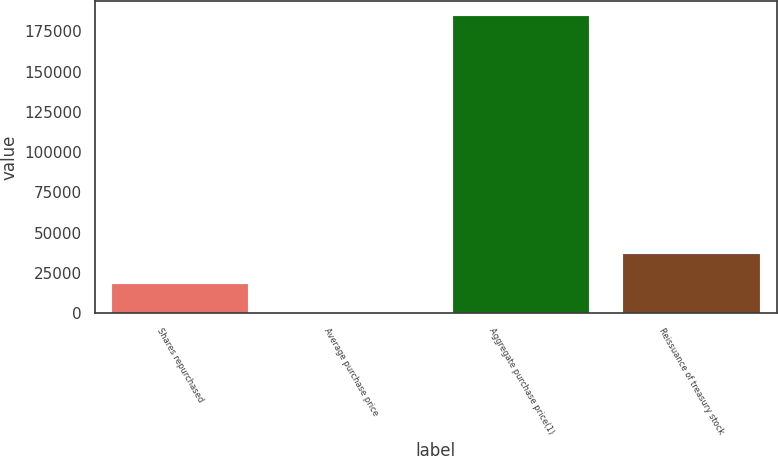Convert chart to OTSL. <chart><loc_0><loc_0><loc_500><loc_500><bar_chart><fcel>Shares repurchased<fcel>Average purchase price<fcel>Aggregate purchase price(1)<fcel>Reissuance of treasury stock<nl><fcel>18490.1<fcel>22.43<fcel>184699<fcel>36957.8<nl></chart> 